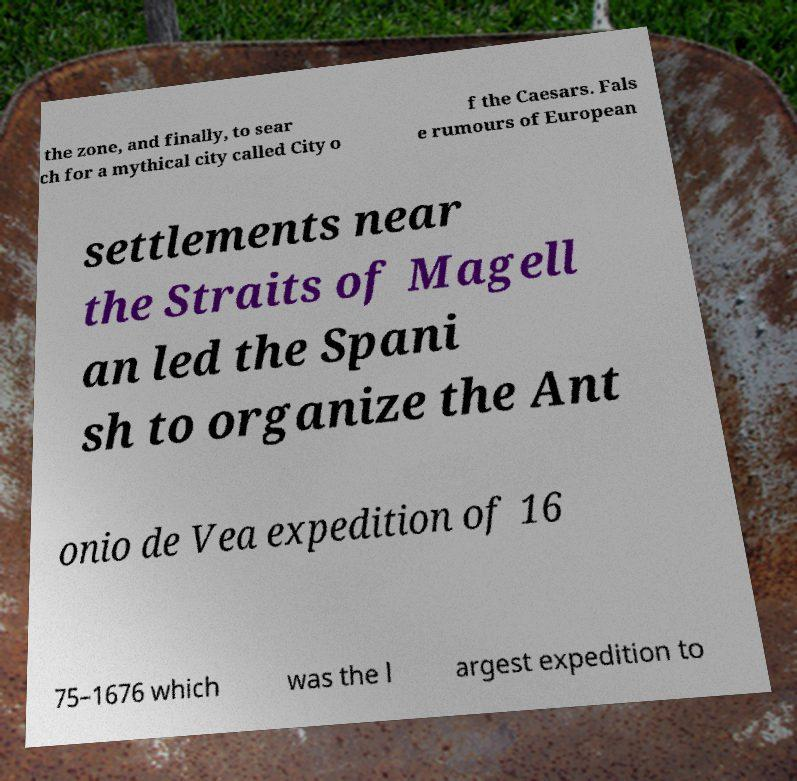What messages or text are displayed in this image? I need them in a readable, typed format. the zone, and finally, to sear ch for a mythical city called City o f the Caesars. Fals e rumours of European settlements near the Straits of Magell an led the Spani sh to organize the Ant onio de Vea expedition of 16 75–1676 which was the l argest expedition to 